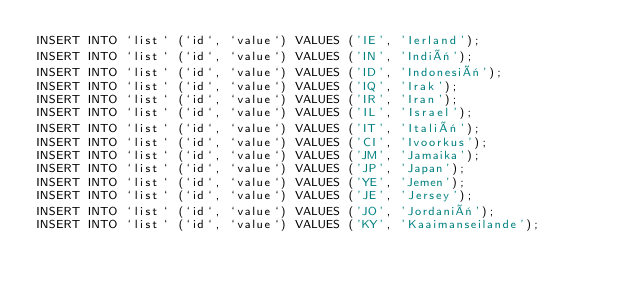Convert code to text. <code><loc_0><loc_0><loc_500><loc_500><_SQL_>INSERT INTO `list` (`id`, `value`) VALUES ('IE', 'Ierland');
INSERT INTO `list` (`id`, `value`) VALUES ('IN', 'Indië');
INSERT INTO `list` (`id`, `value`) VALUES ('ID', 'Indonesië');
INSERT INTO `list` (`id`, `value`) VALUES ('IQ', 'Irak');
INSERT INTO `list` (`id`, `value`) VALUES ('IR', 'Iran');
INSERT INTO `list` (`id`, `value`) VALUES ('IL', 'Israel');
INSERT INTO `list` (`id`, `value`) VALUES ('IT', 'Italië');
INSERT INTO `list` (`id`, `value`) VALUES ('CI', 'Ivoorkus');
INSERT INTO `list` (`id`, `value`) VALUES ('JM', 'Jamaika');
INSERT INTO `list` (`id`, `value`) VALUES ('JP', 'Japan');
INSERT INTO `list` (`id`, `value`) VALUES ('YE', 'Jemen');
INSERT INTO `list` (`id`, `value`) VALUES ('JE', 'Jersey');
INSERT INTO `list` (`id`, `value`) VALUES ('JO', 'Jordanië');
INSERT INTO `list` (`id`, `value`) VALUES ('KY', 'Kaaimanseilande');</code> 